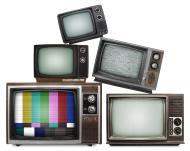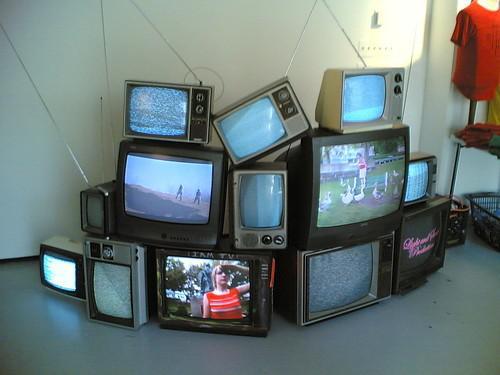The first image is the image on the left, the second image is the image on the right. For the images shown, is this caption "In one image, an arrangement of old televisions that are turned on to various channels is stacked at least three high, while a second image shows exactly five television or computer screens." true? Answer yes or no. Yes. The first image is the image on the left, the second image is the image on the right. Given the left and right images, does the statement "There are exactly five televisions in the image on the left." hold true? Answer yes or no. Yes. 